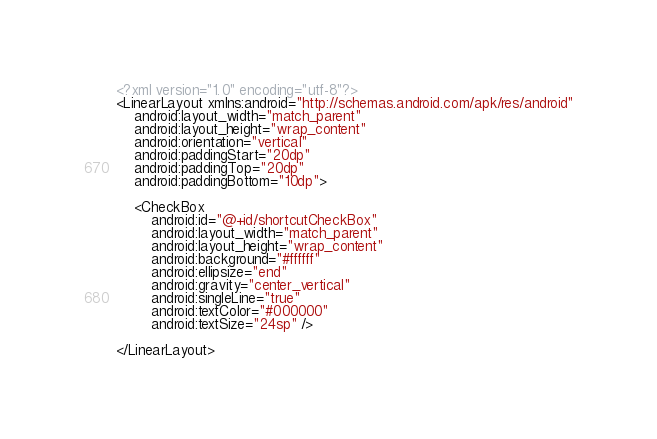<code> <loc_0><loc_0><loc_500><loc_500><_XML_><?xml version="1.0" encoding="utf-8"?>
<LinearLayout xmlns:android="http://schemas.android.com/apk/res/android"
    android:layout_width="match_parent"
    android:layout_height="wrap_content"
    android:orientation="vertical"
    android:paddingStart="20dp"
    android:paddingTop="20dp"
    android:paddingBottom="10dp">

    <CheckBox
        android:id="@+id/shortcutCheckBox"
        android:layout_width="match_parent"
        android:layout_height="wrap_content"
        android:background="#ffffff"
        android:ellipsize="end"
        android:gravity="center_vertical"
        android:singleLine="true"
        android:textColor="#000000"
        android:textSize="24sp" />

</LinearLayout>
</code> 